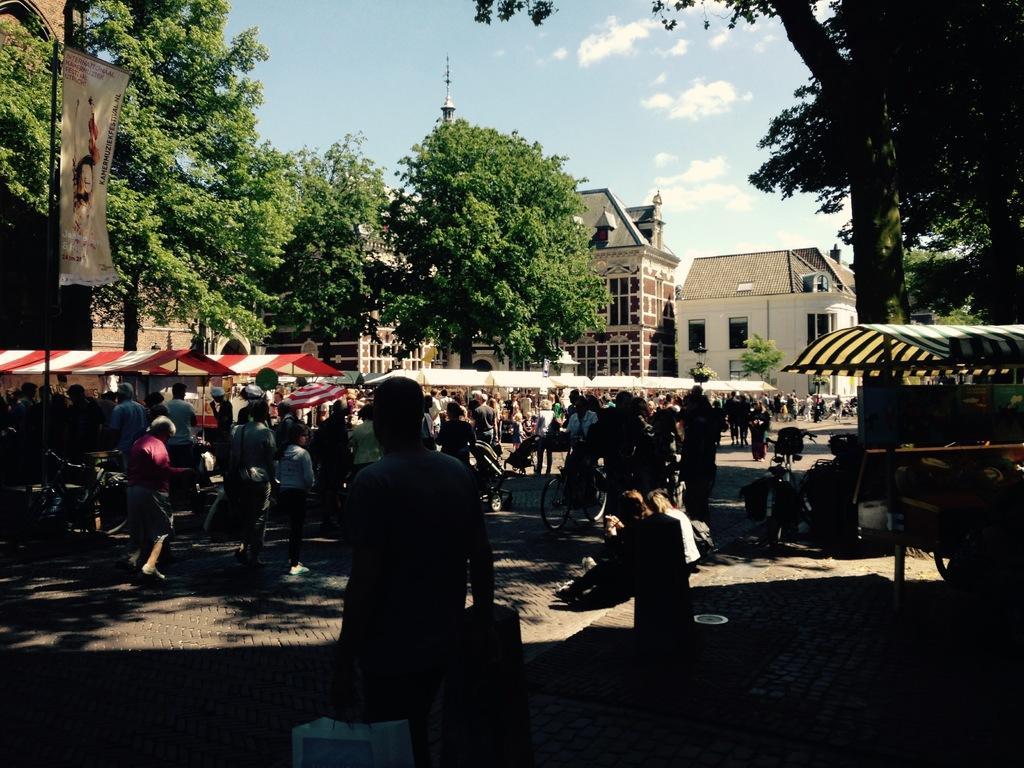Please provide a concise description of this image. In this image there is a person standing on the floor by wearing the hat and holding the bag. On the left side there are so many people under the tents. In the background there are buildings on either side of the image. There are trees In between them. On the right side there is a tent under which there are few cycles parked under it. In the middle there is a person cycling on the floor. At the top there is the sky. On the left side there is a banner attached to the pole. 